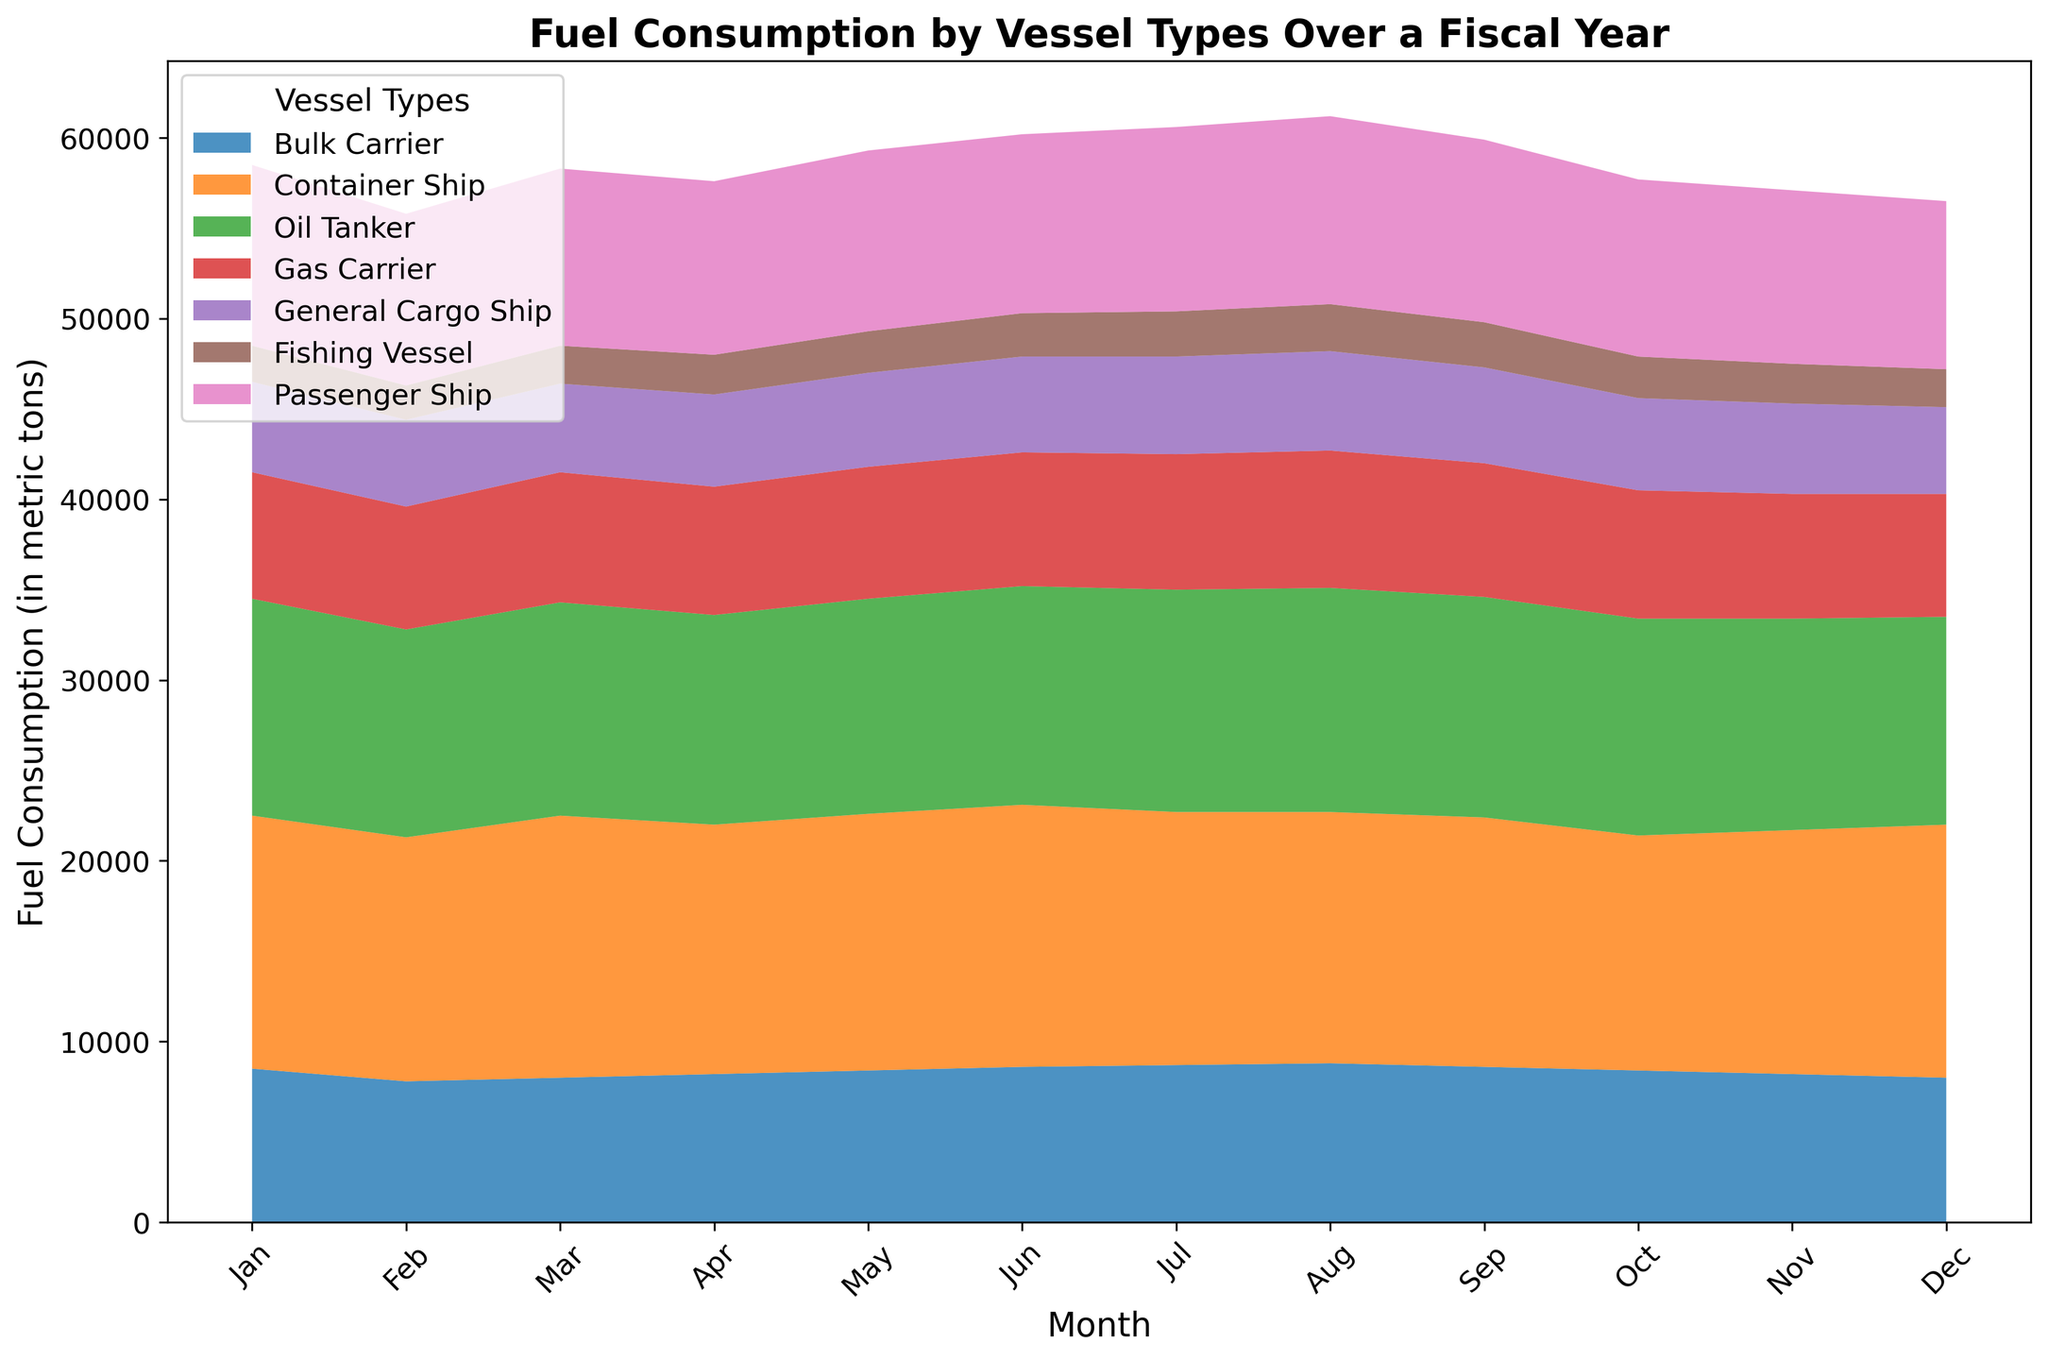what is the total fuel consumption of oil tankers in the second quarter? Look at the months April, May, and June for oil tankers: 11600 (April) + 11900 (May) + 12100 (June). Sum these values: 11600 + 11900 + 12100 = 35600
Answer: 35600 which vessel type consumes the least fuel in December? Observe the height of the area segments in December. The Fishing Vessel area is the smallest, indicating the least fuel consumption.
Answer: Fishing Vessel how does the fuel consumption of passenger ships in January compare to February? Check the area height for passenger ships in January and February: January is 10000 and February is 9500. Compare these values: 10000 > 9500
Answer: January has higher consumption What is the average fuel consumption of container ships over the entire year? Sum all monthly fuel consumptions for container ships and divide by 12: (14000 + 13500 + 14500 + 13800 + 14200 + 14500 + 14000 + 13900 + 13800 + 13000 + 13500 + 14000) / 12. The sum is 165700: 165700 / 12 = 13808.33
Answer: 13808.33 In which month do bulk carriers have the highest fuel consumption? Scan the bulk carrier section for each month. Bulk Carriers have the highest in August with 8800
Answer: August Compare the fuel usage of gas carriers from July to October. Is there a trend? Check the values for gas carriers: July (7500), August (7600), September (7400), October (7100). Observe the trend: it decreases from August to October.
Answer: Decline What is the combined fuel usage for general cargo ships and fishing vessels in March? Add the values for general cargo ships and fishing vessels in March: 4900 (General Cargo Ship) + 2100 (Fishing Vessel). Sum these: 4900 + 2100 = 7000
Answer: 7000 By how much does the fuel consumption of passenger ships vary between the month with the highest usage and the month with the lowest usage? Highest is in August (10400) and lowest is November (9600): 10400 - 9600 = 800
Answer: 800 Which vessel type has the most consistent fuel consumption throughout the year? Look at the area chart and compare the fluctuations. General Cargo Ships have relatively stable consumption.
Answer: General Cargo Ship 